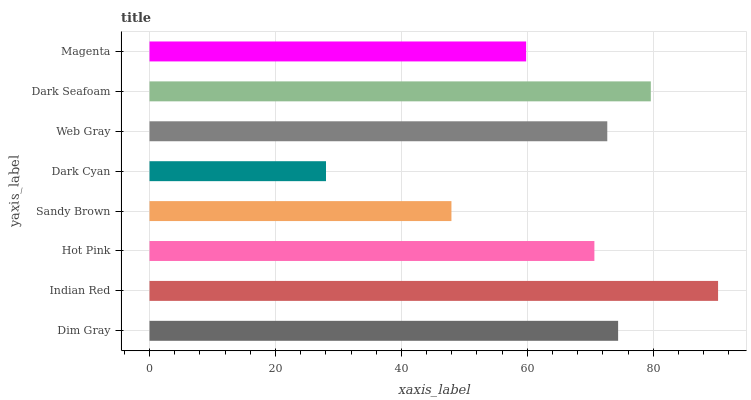Is Dark Cyan the minimum?
Answer yes or no. Yes. Is Indian Red the maximum?
Answer yes or no. Yes. Is Hot Pink the minimum?
Answer yes or no. No. Is Hot Pink the maximum?
Answer yes or no. No. Is Indian Red greater than Hot Pink?
Answer yes or no. Yes. Is Hot Pink less than Indian Red?
Answer yes or no. Yes. Is Hot Pink greater than Indian Red?
Answer yes or no. No. Is Indian Red less than Hot Pink?
Answer yes or no. No. Is Web Gray the high median?
Answer yes or no. Yes. Is Hot Pink the low median?
Answer yes or no. Yes. Is Dark Cyan the high median?
Answer yes or no. No. Is Magenta the low median?
Answer yes or no. No. 